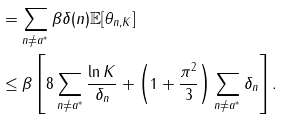<formula> <loc_0><loc_0><loc_500><loc_500>& = \sum _ { n \neq a ^ { * } } \beta \delta ( n ) \mathbb { E } [ \theta _ { n , K } ] \\ & \leq \beta \left [ 8 \sum _ { n \neq a ^ { * } } \frac { \ln K } { \delta _ { n } } + \left ( 1 + \frac { \pi ^ { 2 } } { 3 } \right ) \sum _ { n \neq a ^ { * } } \delta _ { n } \right ] .</formula> 